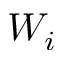<formula> <loc_0><loc_0><loc_500><loc_500>W _ { i }</formula> 